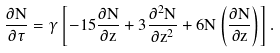Convert formula to latex. <formula><loc_0><loc_0><loc_500><loc_500>\frac { \partial N } { \partial \tau } = \gamma \left [ - 1 5 \frac { \partial N } { \partial z } + 3 \frac { \partial ^ { 2 } N } { \partial z ^ { 2 } } + 6 N \left ( \frac { \partial N } { \partial z } \right ) \right ] .</formula> 